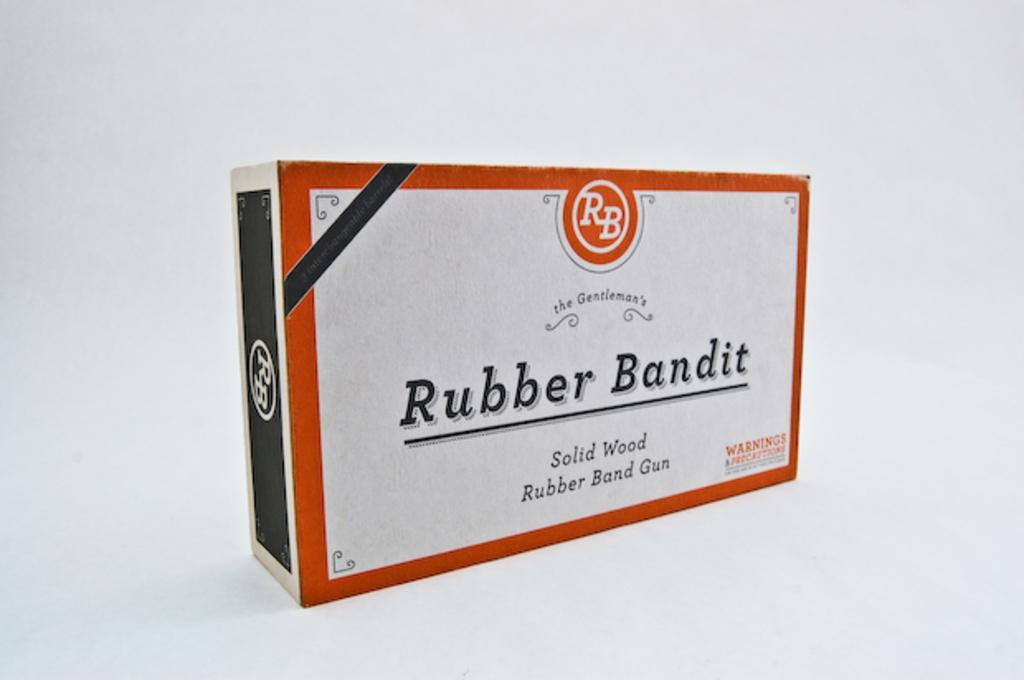<image>
Summarize the visual content of the image. A box for Rubber Bandit sits against a white background 